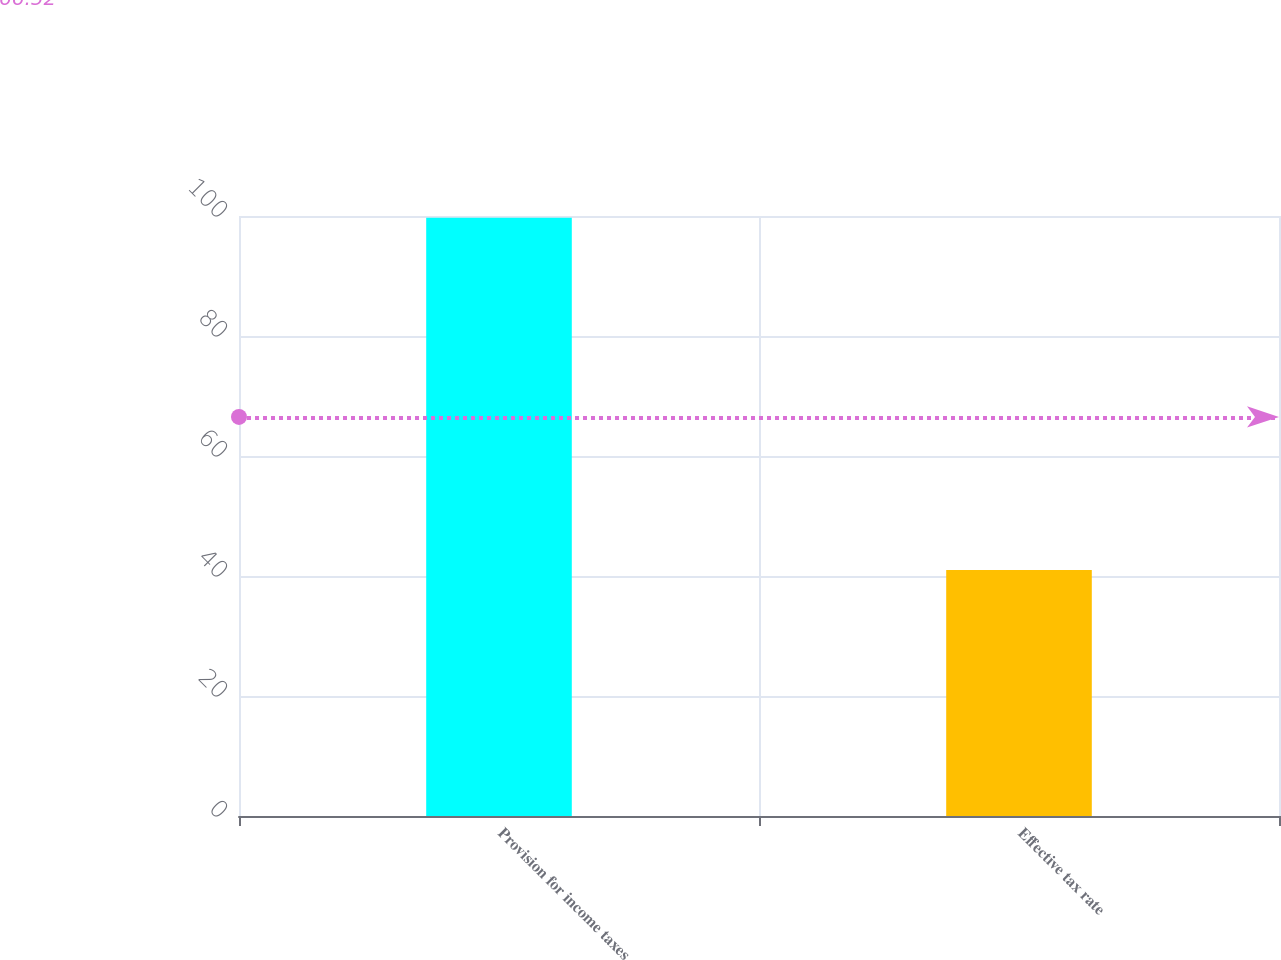Convert chart to OTSL. <chart><loc_0><loc_0><loc_500><loc_500><bar_chart><fcel>Provision for income taxes<fcel>Effective tax rate<nl><fcel>99.7<fcel>41<nl></chart> 